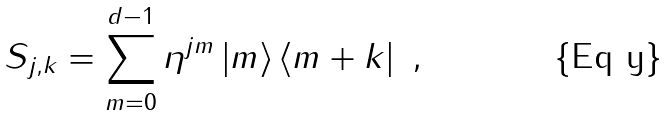<formula> <loc_0><loc_0><loc_500><loc_500>S _ { j , k } = \sum _ { m = 0 } ^ { d - 1 } \eta ^ { j m } \left | m \right \rangle \left \langle m + k \right | \ ,</formula> 